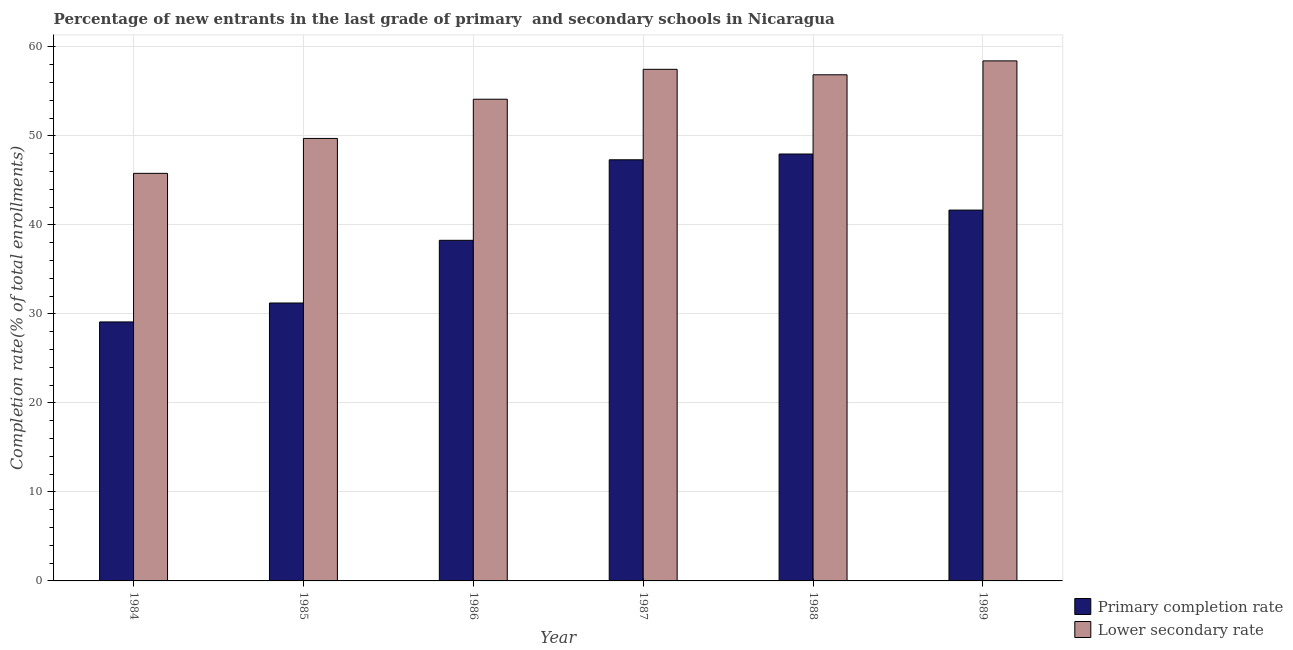How many different coloured bars are there?
Offer a terse response. 2. Are the number of bars on each tick of the X-axis equal?
Your response must be concise. Yes. How many bars are there on the 5th tick from the left?
Your answer should be very brief. 2. What is the label of the 4th group of bars from the left?
Your answer should be compact. 1987. In how many cases, is the number of bars for a given year not equal to the number of legend labels?
Offer a very short reply. 0. What is the completion rate in secondary schools in 1985?
Give a very brief answer. 49.72. Across all years, what is the maximum completion rate in primary schools?
Ensure brevity in your answer.  47.97. Across all years, what is the minimum completion rate in secondary schools?
Make the answer very short. 45.8. In which year was the completion rate in secondary schools maximum?
Offer a very short reply. 1989. What is the total completion rate in primary schools in the graph?
Your answer should be compact. 235.57. What is the difference between the completion rate in primary schools in 1984 and that in 1987?
Give a very brief answer. -18.22. What is the difference between the completion rate in primary schools in 1988 and the completion rate in secondary schools in 1985?
Your answer should be very brief. 16.74. What is the average completion rate in secondary schools per year?
Your answer should be very brief. 53.74. In how many years, is the completion rate in primary schools greater than 52 %?
Offer a terse response. 0. What is the ratio of the completion rate in primary schools in 1985 to that in 1987?
Your answer should be compact. 0.66. Is the completion rate in primary schools in 1984 less than that in 1985?
Provide a succinct answer. Yes. What is the difference between the highest and the second highest completion rate in primary schools?
Your response must be concise. 0.65. What is the difference between the highest and the lowest completion rate in secondary schools?
Offer a very short reply. 12.64. In how many years, is the completion rate in primary schools greater than the average completion rate in primary schools taken over all years?
Keep it short and to the point. 3. Is the sum of the completion rate in secondary schools in 1984 and 1988 greater than the maximum completion rate in primary schools across all years?
Provide a succinct answer. Yes. What does the 1st bar from the left in 1989 represents?
Provide a short and direct response. Primary completion rate. What does the 1st bar from the right in 1984 represents?
Ensure brevity in your answer.  Lower secondary rate. How many years are there in the graph?
Ensure brevity in your answer.  6. What is the difference between two consecutive major ticks on the Y-axis?
Your answer should be very brief. 10. Are the values on the major ticks of Y-axis written in scientific E-notation?
Provide a short and direct response. No. Does the graph contain any zero values?
Keep it short and to the point. No. Does the graph contain grids?
Ensure brevity in your answer.  Yes. How many legend labels are there?
Your response must be concise. 2. What is the title of the graph?
Offer a very short reply. Percentage of new entrants in the last grade of primary  and secondary schools in Nicaragua. What is the label or title of the X-axis?
Ensure brevity in your answer.  Year. What is the label or title of the Y-axis?
Provide a succinct answer. Completion rate(% of total enrollments). What is the Completion rate(% of total enrollments) in Primary completion rate in 1984?
Give a very brief answer. 29.1. What is the Completion rate(% of total enrollments) in Lower secondary rate in 1984?
Make the answer very short. 45.8. What is the Completion rate(% of total enrollments) in Primary completion rate in 1985?
Provide a succinct answer. 31.23. What is the Completion rate(% of total enrollments) in Lower secondary rate in 1985?
Provide a succinct answer. 49.72. What is the Completion rate(% of total enrollments) in Primary completion rate in 1986?
Give a very brief answer. 38.27. What is the Completion rate(% of total enrollments) in Lower secondary rate in 1986?
Your answer should be very brief. 54.13. What is the Completion rate(% of total enrollments) of Primary completion rate in 1987?
Ensure brevity in your answer.  47.32. What is the Completion rate(% of total enrollments) of Lower secondary rate in 1987?
Offer a very short reply. 57.49. What is the Completion rate(% of total enrollments) in Primary completion rate in 1988?
Your answer should be very brief. 47.97. What is the Completion rate(% of total enrollments) of Lower secondary rate in 1988?
Offer a very short reply. 56.87. What is the Completion rate(% of total enrollments) of Primary completion rate in 1989?
Provide a succinct answer. 41.67. What is the Completion rate(% of total enrollments) in Lower secondary rate in 1989?
Keep it short and to the point. 58.44. Across all years, what is the maximum Completion rate(% of total enrollments) in Primary completion rate?
Your response must be concise. 47.97. Across all years, what is the maximum Completion rate(% of total enrollments) of Lower secondary rate?
Your response must be concise. 58.44. Across all years, what is the minimum Completion rate(% of total enrollments) in Primary completion rate?
Offer a very short reply. 29.1. Across all years, what is the minimum Completion rate(% of total enrollments) of Lower secondary rate?
Provide a succinct answer. 45.8. What is the total Completion rate(% of total enrollments) of Primary completion rate in the graph?
Ensure brevity in your answer.  235.57. What is the total Completion rate(% of total enrollments) in Lower secondary rate in the graph?
Your response must be concise. 322.44. What is the difference between the Completion rate(% of total enrollments) of Primary completion rate in 1984 and that in 1985?
Offer a very short reply. -2.13. What is the difference between the Completion rate(% of total enrollments) of Lower secondary rate in 1984 and that in 1985?
Your answer should be very brief. -3.92. What is the difference between the Completion rate(% of total enrollments) of Primary completion rate in 1984 and that in 1986?
Offer a very short reply. -9.17. What is the difference between the Completion rate(% of total enrollments) in Lower secondary rate in 1984 and that in 1986?
Offer a terse response. -8.33. What is the difference between the Completion rate(% of total enrollments) of Primary completion rate in 1984 and that in 1987?
Offer a terse response. -18.22. What is the difference between the Completion rate(% of total enrollments) of Lower secondary rate in 1984 and that in 1987?
Offer a very short reply. -11.69. What is the difference between the Completion rate(% of total enrollments) of Primary completion rate in 1984 and that in 1988?
Offer a terse response. -18.87. What is the difference between the Completion rate(% of total enrollments) of Lower secondary rate in 1984 and that in 1988?
Your response must be concise. -11.07. What is the difference between the Completion rate(% of total enrollments) in Primary completion rate in 1984 and that in 1989?
Your answer should be very brief. -12.57. What is the difference between the Completion rate(% of total enrollments) of Lower secondary rate in 1984 and that in 1989?
Provide a short and direct response. -12.64. What is the difference between the Completion rate(% of total enrollments) of Primary completion rate in 1985 and that in 1986?
Offer a very short reply. -7.04. What is the difference between the Completion rate(% of total enrollments) in Lower secondary rate in 1985 and that in 1986?
Provide a succinct answer. -4.41. What is the difference between the Completion rate(% of total enrollments) of Primary completion rate in 1985 and that in 1987?
Make the answer very short. -16.09. What is the difference between the Completion rate(% of total enrollments) in Lower secondary rate in 1985 and that in 1987?
Your response must be concise. -7.77. What is the difference between the Completion rate(% of total enrollments) in Primary completion rate in 1985 and that in 1988?
Your answer should be very brief. -16.74. What is the difference between the Completion rate(% of total enrollments) of Lower secondary rate in 1985 and that in 1988?
Provide a short and direct response. -7.15. What is the difference between the Completion rate(% of total enrollments) of Primary completion rate in 1985 and that in 1989?
Provide a short and direct response. -10.44. What is the difference between the Completion rate(% of total enrollments) of Lower secondary rate in 1985 and that in 1989?
Offer a very short reply. -8.71. What is the difference between the Completion rate(% of total enrollments) in Primary completion rate in 1986 and that in 1987?
Keep it short and to the point. -9.05. What is the difference between the Completion rate(% of total enrollments) of Lower secondary rate in 1986 and that in 1987?
Give a very brief answer. -3.36. What is the difference between the Completion rate(% of total enrollments) of Primary completion rate in 1986 and that in 1988?
Make the answer very short. -9.7. What is the difference between the Completion rate(% of total enrollments) of Lower secondary rate in 1986 and that in 1988?
Offer a terse response. -2.75. What is the difference between the Completion rate(% of total enrollments) in Primary completion rate in 1986 and that in 1989?
Give a very brief answer. -3.4. What is the difference between the Completion rate(% of total enrollments) of Lower secondary rate in 1986 and that in 1989?
Offer a terse response. -4.31. What is the difference between the Completion rate(% of total enrollments) of Primary completion rate in 1987 and that in 1988?
Ensure brevity in your answer.  -0.65. What is the difference between the Completion rate(% of total enrollments) of Lower secondary rate in 1987 and that in 1988?
Give a very brief answer. 0.62. What is the difference between the Completion rate(% of total enrollments) in Primary completion rate in 1987 and that in 1989?
Keep it short and to the point. 5.65. What is the difference between the Completion rate(% of total enrollments) in Lower secondary rate in 1987 and that in 1989?
Your answer should be very brief. -0.95. What is the difference between the Completion rate(% of total enrollments) in Primary completion rate in 1988 and that in 1989?
Keep it short and to the point. 6.3. What is the difference between the Completion rate(% of total enrollments) in Lower secondary rate in 1988 and that in 1989?
Keep it short and to the point. -1.56. What is the difference between the Completion rate(% of total enrollments) in Primary completion rate in 1984 and the Completion rate(% of total enrollments) in Lower secondary rate in 1985?
Offer a very short reply. -20.62. What is the difference between the Completion rate(% of total enrollments) in Primary completion rate in 1984 and the Completion rate(% of total enrollments) in Lower secondary rate in 1986?
Your answer should be compact. -25.02. What is the difference between the Completion rate(% of total enrollments) in Primary completion rate in 1984 and the Completion rate(% of total enrollments) in Lower secondary rate in 1987?
Your answer should be very brief. -28.39. What is the difference between the Completion rate(% of total enrollments) in Primary completion rate in 1984 and the Completion rate(% of total enrollments) in Lower secondary rate in 1988?
Offer a terse response. -27.77. What is the difference between the Completion rate(% of total enrollments) in Primary completion rate in 1984 and the Completion rate(% of total enrollments) in Lower secondary rate in 1989?
Your response must be concise. -29.33. What is the difference between the Completion rate(% of total enrollments) of Primary completion rate in 1985 and the Completion rate(% of total enrollments) of Lower secondary rate in 1986?
Your response must be concise. -22.9. What is the difference between the Completion rate(% of total enrollments) of Primary completion rate in 1985 and the Completion rate(% of total enrollments) of Lower secondary rate in 1987?
Your response must be concise. -26.26. What is the difference between the Completion rate(% of total enrollments) of Primary completion rate in 1985 and the Completion rate(% of total enrollments) of Lower secondary rate in 1988?
Keep it short and to the point. -25.64. What is the difference between the Completion rate(% of total enrollments) of Primary completion rate in 1985 and the Completion rate(% of total enrollments) of Lower secondary rate in 1989?
Give a very brief answer. -27.21. What is the difference between the Completion rate(% of total enrollments) in Primary completion rate in 1986 and the Completion rate(% of total enrollments) in Lower secondary rate in 1987?
Give a very brief answer. -19.21. What is the difference between the Completion rate(% of total enrollments) of Primary completion rate in 1986 and the Completion rate(% of total enrollments) of Lower secondary rate in 1988?
Provide a short and direct response. -18.6. What is the difference between the Completion rate(% of total enrollments) in Primary completion rate in 1986 and the Completion rate(% of total enrollments) in Lower secondary rate in 1989?
Your response must be concise. -20.16. What is the difference between the Completion rate(% of total enrollments) of Primary completion rate in 1987 and the Completion rate(% of total enrollments) of Lower secondary rate in 1988?
Provide a short and direct response. -9.55. What is the difference between the Completion rate(% of total enrollments) in Primary completion rate in 1987 and the Completion rate(% of total enrollments) in Lower secondary rate in 1989?
Provide a succinct answer. -11.11. What is the difference between the Completion rate(% of total enrollments) in Primary completion rate in 1988 and the Completion rate(% of total enrollments) in Lower secondary rate in 1989?
Your answer should be very brief. -10.47. What is the average Completion rate(% of total enrollments) in Primary completion rate per year?
Your answer should be very brief. 39.26. What is the average Completion rate(% of total enrollments) in Lower secondary rate per year?
Keep it short and to the point. 53.74. In the year 1984, what is the difference between the Completion rate(% of total enrollments) of Primary completion rate and Completion rate(% of total enrollments) of Lower secondary rate?
Offer a very short reply. -16.69. In the year 1985, what is the difference between the Completion rate(% of total enrollments) in Primary completion rate and Completion rate(% of total enrollments) in Lower secondary rate?
Provide a succinct answer. -18.49. In the year 1986, what is the difference between the Completion rate(% of total enrollments) of Primary completion rate and Completion rate(% of total enrollments) of Lower secondary rate?
Give a very brief answer. -15.85. In the year 1987, what is the difference between the Completion rate(% of total enrollments) of Primary completion rate and Completion rate(% of total enrollments) of Lower secondary rate?
Offer a very short reply. -10.17. In the year 1988, what is the difference between the Completion rate(% of total enrollments) of Primary completion rate and Completion rate(% of total enrollments) of Lower secondary rate?
Make the answer very short. -8.9. In the year 1989, what is the difference between the Completion rate(% of total enrollments) in Primary completion rate and Completion rate(% of total enrollments) in Lower secondary rate?
Your answer should be compact. -16.77. What is the ratio of the Completion rate(% of total enrollments) of Primary completion rate in 1984 to that in 1985?
Keep it short and to the point. 0.93. What is the ratio of the Completion rate(% of total enrollments) of Lower secondary rate in 1984 to that in 1985?
Ensure brevity in your answer.  0.92. What is the ratio of the Completion rate(% of total enrollments) in Primary completion rate in 1984 to that in 1986?
Ensure brevity in your answer.  0.76. What is the ratio of the Completion rate(% of total enrollments) of Lower secondary rate in 1984 to that in 1986?
Make the answer very short. 0.85. What is the ratio of the Completion rate(% of total enrollments) in Primary completion rate in 1984 to that in 1987?
Ensure brevity in your answer.  0.61. What is the ratio of the Completion rate(% of total enrollments) in Lower secondary rate in 1984 to that in 1987?
Offer a terse response. 0.8. What is the ratio of the Completion rate(% of total enrollments) of Primary completion rate in 1984 to that in 1988?
Your response must be concise. 0.61. What is the ratio of the Completion rate(% of total enrollments) of Lower secondary rate in 1984 to that in 1988?
Your response must be concise. 0.81. What is the ratio of the Completion rate(% of total enrollments) in Primary completion rate in 1984 to that in 1989?
Your answer should be very brief. 0.7. What is the ratio of the Completion rate(% of total enrollments) of Lower secondary rate in 1984 to that in 1989?
Offer a terse response. 0.78. What is the ratio of the Completion rate(% of total enrollments) of Primary completion rate in 1985 to that in 1986?
Keep it short and to the point. 0.82. What is the ratio of the Completion rate(% of total enrollments) in Lower secondary rate in 1985 to that in 1986?
Your answer should be very brief. 0.92. What is the ratio of the Completion rate(% of total enrollments) in Primary completion rate in 1985 to that in 1987?
Make the answer very short. 0.66. What is the ratio of the Completion rate(% of total enrollments) in Lower secondary rate in 1985 to that in 1987?
Keep it short and to the point. 0.86. What is the ratio of the Completion rate(% of total enrollments) in Primary completion rate in 1985 to that in 1988?
Offer a very short reply. 0.65. What is the ratio of the Completion rate(% of total enrollments) of Lower secondary rate in 1985 to that in 1988?
Give a very brief answer. 0.87. What is the ratio of the Completion rate(% of total enrollments) in Primary completion rate in 1985 to that in 1989?
Ensure brevity in your answer.  0.75. What is the ratio of the Completion rate(% of total enrollments) of Lower secondary rate in 1985 to that in 1989?
Make the answer very short. 0.85. What is the ratio of the Completion rate(% of total enrollments) of Primary completion rate in 1986 to that in 1987?
Offer a terse response. 0.81. What is the ratio of the Completion rate(% of total enrollments) in Lower secondary rate in 1986 to that in 1987?
Make the answer very short. 0.94. What is the ratio of the Completion rate(% of total enrollments) in Primary completion rate in 1986 to that in 1988?
Your answer should be very brief. 0.8. What is the ratio of the Completion rate(% of total enrollments) of Lower secondary rate in 1986 to that in 1988?
Ensure brevity in your answer.  0.95. What is the ratio of the Completion rate(% of total enrollments) of Primary completion rate in 1986 to that in 1989?
Your answer should be very brief. 0.92. What is the ratio of the Completion rate(% of total enrollments) of Lower secondary rate in 1986 to that in 1989?
Make the answer very short. 0.93. What is the ratio of the Completion rate(% of total enrollments) of Primary completion rate in 1987 to that in 1988?
Provide a succinct answer. 0.99. What is the ratio of the Completion rate(% of total enrollments) in Lower secondary rate in 1987 to that in 1988?
Provide a short and direct response. 1.01. What is the ratio of the Completion rate(% of total enrollments) of Primary completion rate in 1987 to that in 1989?
Provide a short and direct response. 1.14. What is the ratio of the Completion rate(% of total enrollments) of Lower secondary rate in 1987 to that in 1989?
Offer a terse response. 0.98. What is the ratio of the Completion rate(% of total enrollments) of Primary completion rate in 1988 to that in 1989?
Your answer should be compact. 1.15. What is the ratio of the Completion rate(% of total enrollments) of Lower secondary rate in 1988 to that in 1989?
Offer a very short reply. 0.97. What is the difference between the highest and the second highest Completion rate(% of total enrollments) of Primary completion rate?
Offer a very short reply. 0.65. What is the difference between the highest and the second highest Completion rate(% of total enrollments) in Lower secondary rate?
Provide a succinct answer. 0.95. What is the difference between the highest and the lowest Completion rate(% of total enrollments) of Primary completion rate?
Keep it short and to the point. 18.87. What is the difference between the highest and the lowest Completion rate(% of total enrollments) in Lower secondary rate?
Give a very brief answer. 12.64. 